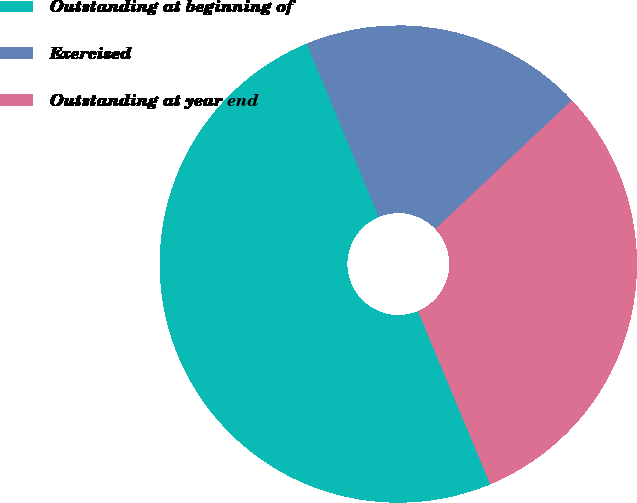<chart> <loc_0><loc_0><loc_500><loc_500><pie_chart><fcel>Outstanding at beginning of<fcel>Exercised<fcel>Outstanding at year end<nl><fcel>50.03%<fcel>19.23%<fcel>30.74%<nl></chart> 